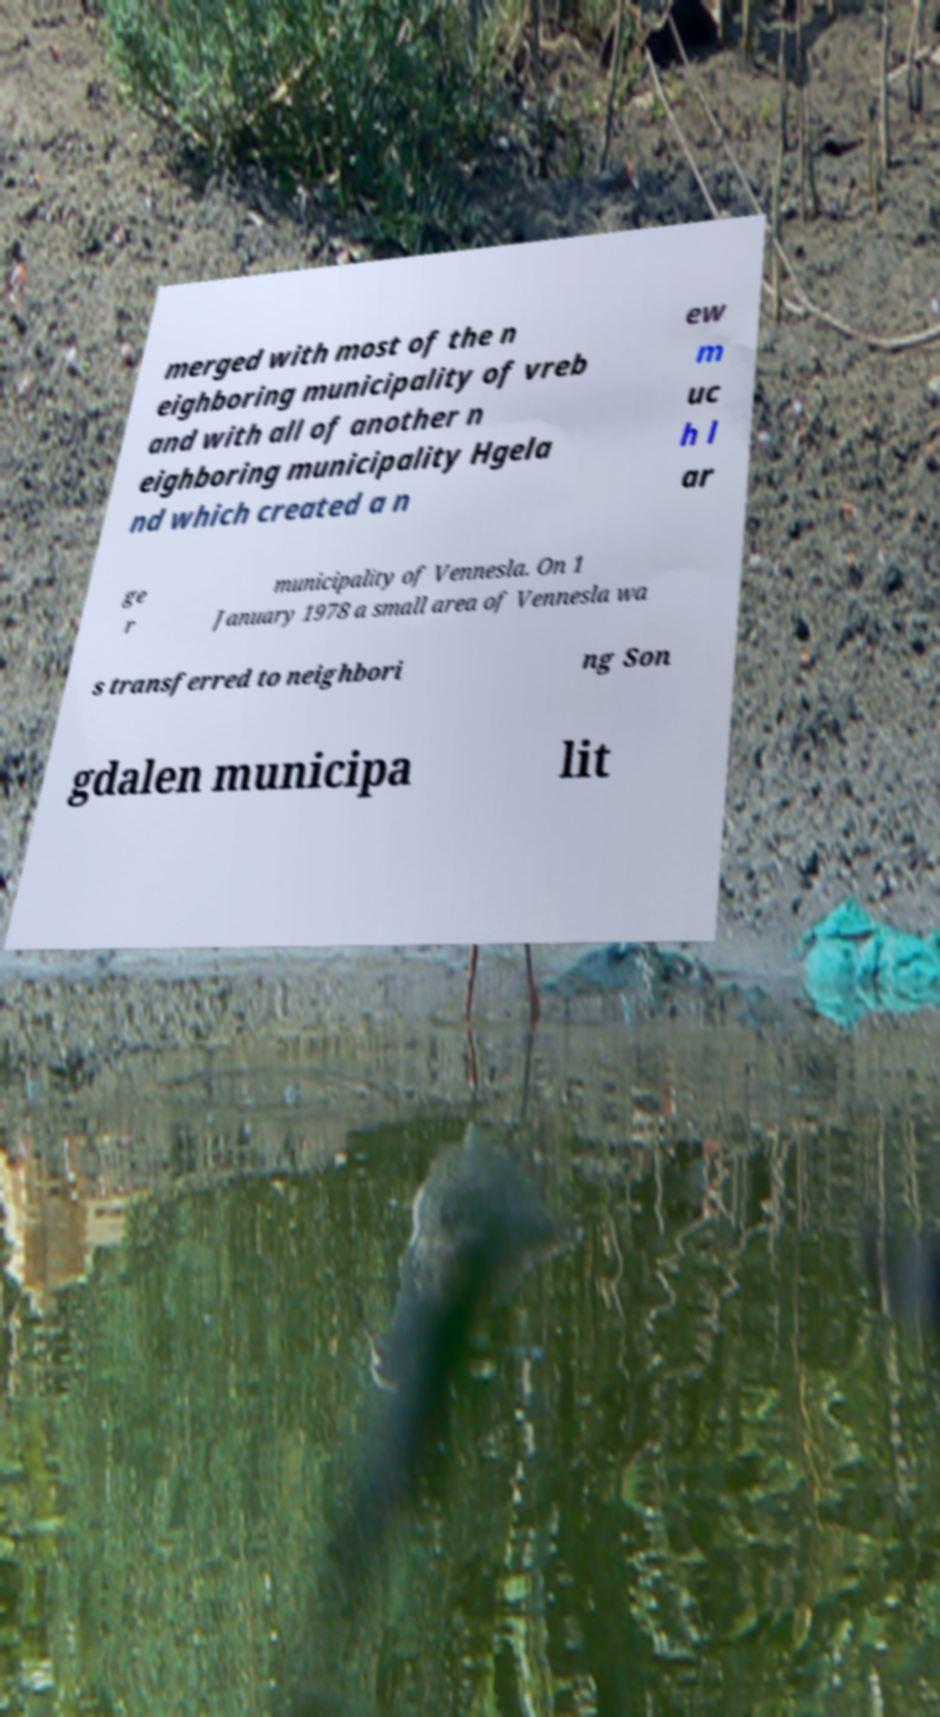For documentation purposes, I need the text within this image transcribed. Could you provide that? merged with most of the n eighboring municipality of vreb and with all of another n eighboring municipality Hgela nd which created a n ew m uc h l ar ge r municipality of Vennesla. On 1 January 1978 a small area of Vennesla wa s transferred to neighbori ng Son gdalen municipa lit 